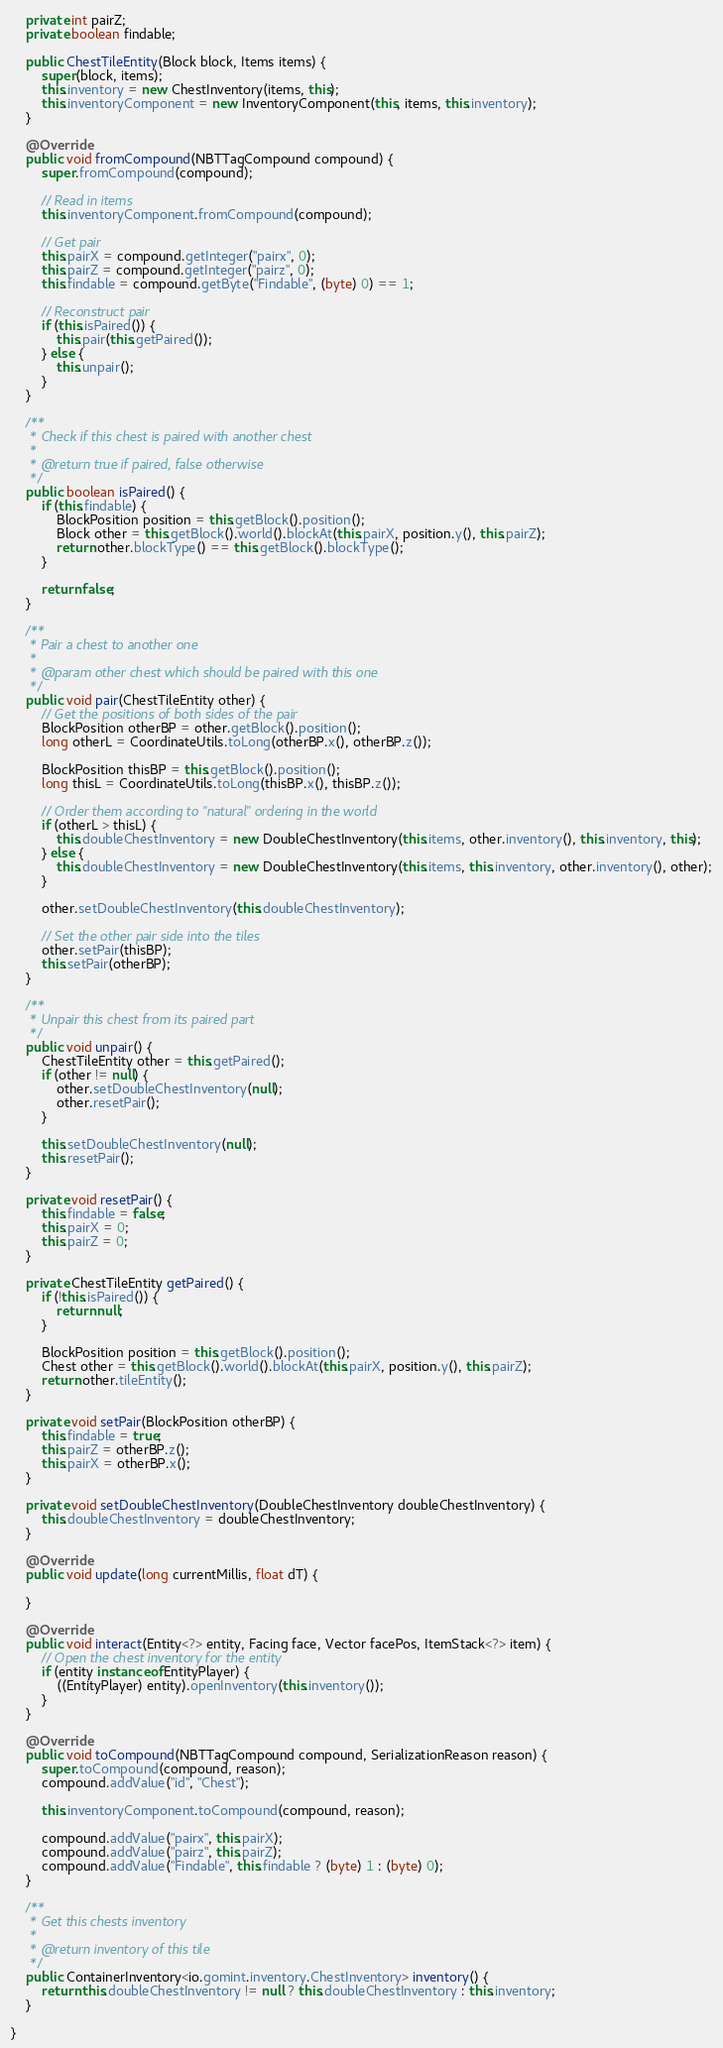<code> <loc_0><loc_0><loc_500><loc_500><_Java_>    private int pairZ;
    private boolean findable;

    public ChestTileEntity(Block block, Items items) {
        super(block, items);
        this.inventory = new ChestInventory(items, this);
        this.inventoryComponent = new InventoryComponent(this, items, this.inventory);
    }

    @Override
    public void fromCompound(NBTTagCompound compound) {
        super.fromCompound(compound);

        // Read in items
        this.inventoryComponent.fromCompound(compound);

        // Get pair
        this.pairX = compound.getInteger("pairx", 0);
        this.pairZ = compound.getInteger("pairz", 0);
        this.findable = compound.getByte("Findable", (byte) 0) == 1;

        // Reconstruct pair
        if (this.isPaired()) {
            this.pair(this.getPaired());
        } else {
            this.unpair();
        }
    }

    /**
     * Check if this chest is paired with another chest
     *
     * @return true if paired, false otherwise
     */
    public boolean isPaired() {
        if (this.findable) {
            BlockPosition position = this.getBlock().position();
            Block other = this.getBlock().world().blockAt(this.pairX, position.y(), this.pairZ);
            return other.blockType() == this.getBlock().blockType();
        }

        return false;
    }

    /**
     * Pair a chest to another one
     *
     * @param other chest which should be paired with this one
     */
    public void pair(ChestTileEntity other) {
        // Get the positions of both sides of the pair
        BlockPosition otherBP = other.getBlock().position();
        long otherL = CoordinateUtils.toLong(otherBP.x(), otherBP.z());

        BlockPosition thisBP = this.getBlock().position();
        long thisL = CoordinateUtils.toLong(thisBP.x(), thisBP.z());

        // Order them according to "natural" ordering in the world
        if (otherL > thisL) {
            this.doubleChestInventory = new DoubleChestInventory(this.items, other.inventory(), this.inventory, this);
        } else {
            this.doubleChestInventory = new DoubleChestInventory(this.items, this.inventory, other.inventory(), other);
        }

        other.setDoubleChestInventory(this.doubleChestInventory);

        // Set the other pair side into the tiles
        other.setPair(thisBP);
        this.setPair(otherBP);
    }

    /**
     * Unpair this chest from its paired part
     */
    public void unpair() {
        ChestTileEntity other = this.getPaired();
        if (other != null) {
            other.setDoubleChestInventory(null);
            other.resetPair();
        }

        this.setDoubleChestInventory(null);
        this.resetPair();
    }

    private void resetPair() {
        this.findable = false;
        this.pairX = 0;
        this.pairZ = 0;
    }

    private ChestTileEntity getPaired() {
        if (!this.isPaired()) {
            return null;
        }

        BlockPosition position = this.getBlock().position();
        Chest other = this.getBlock().world().blockAt(this.pairX, position.y(), this.pairZ);
        return other.tileEntity();
    }

    private void setPair(BlockPosition otherBP) {
        this.findable = true;
        this.pairZ = otherBP.z();
        this.pairX = otherBP.x();
    }

    private void setDoubleChestInventory(DoubleChestInventory doubleChestInventory) {
        this.doubleChestInventory = doubleChestInventory;
    }

    @Override
    public void update(long currentMillis, float dT) {

    }

    @Override
    public void interact(Entity<?> entity, Facing face, Vector facePos, ItemStack<?> item) {
        // Open the chest inventory for the entity
        if (entity instanceof EntityPlayer) {
            ((EntityPlayer) entity).openInventory(this.inventory());
        }
    }

    @Override
    public void toCompound(NBTTagCompound compound, SerializationReason reason) {
        super.toCompound(compound, reason);
        compound.addValue("id", "Chest");

        this.inventoryComponent.toCompound(compound, reason);

        compound.addValue("pairx", this.pairX);
        compound.addValue("pairz", this.pairZ);
        compound.addValue("Findable", this.findable ? (byte) 1 : (byte) 0);
    }

    /**
     * Get this chests inventory
     *
     * @return inventory of this tile
     */
    public ContainerInventory<io.gomint.inventory.ChestInventory> inventory() {
        return this.doubleChestInventory != null ? this.doubleChestInventory : this.inventory;
    }

}
</code> 